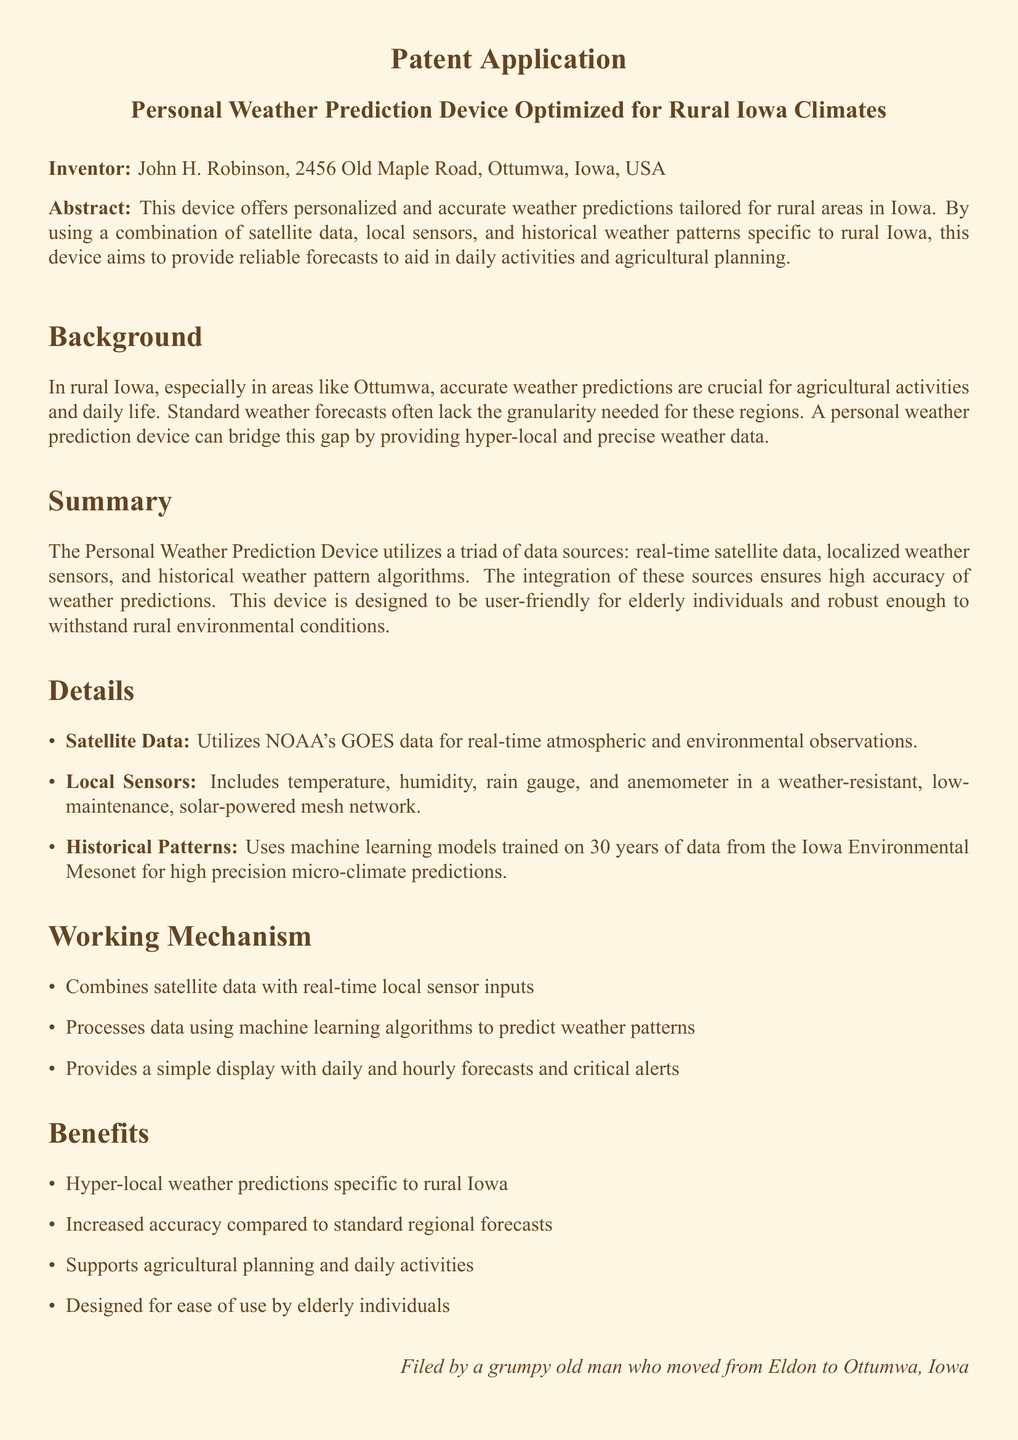What is the title of the patent application? The title of the patent application is explicitly mentioned at the beginning of the document.
Answer: Personal Weather Prediction Device Optimized for Rural Iowa Climates Who is the inventor of the device? The inventor's name and address are clearly presented in the document.
Answer: John H. Robinson, 2456 Old Maple Road, Ottumwa, Iowa, USA What data sources does the device utilize? The device utilizes a triad of data sources, as specified in the document.
Answer: Satellite data, local sensors, and historical weather pattern algorithms How many years of data is used for training the machine learning models? The document states the duration of historical data used for machine learning training.
Answer: 30 years What are the weather parameters measured by local sensors? The details in the document list the specific parameters measured by local sensors.
Answer: Temperature, humidity, rain gauge, and anemometer What is the main benefit of the device for elderly individuals? The document highlights the design aspect that caters to a specific user group.
Answer: Designed for ease of use by elderly individuals What type of weather predictions does the device provide? This is specified in the document, distinguishing the device from standard forecasting.
Answer: Hyper-local weather predictions specific to rural Iowa What is the durability feature of the device mentioned? The document mentions how the device is built to withstand certain conditions.
Answer: Weather-resistant, low-maintenance, solar-powered 